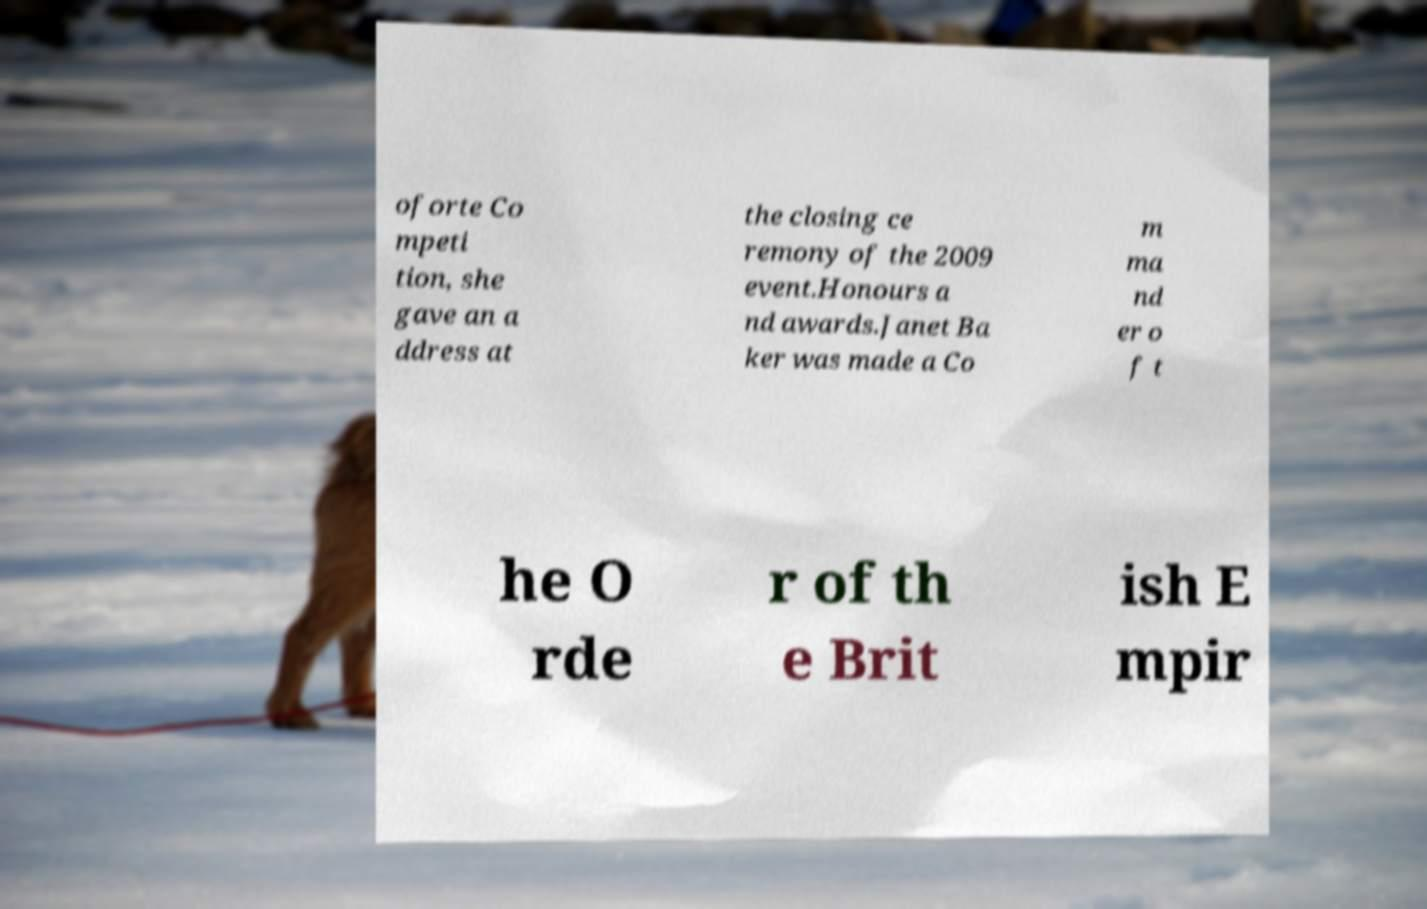For documentation purposes, I need the text within this image transcribed. Could you provide that? oforte Co mpeti tion, she gave an a ddress at the closing ce remony of the 2009 event.Honours a nd awards.Janet Ba ker was made a Co m ma nd er o f t he O rde r of th e Brit ish E mpir 